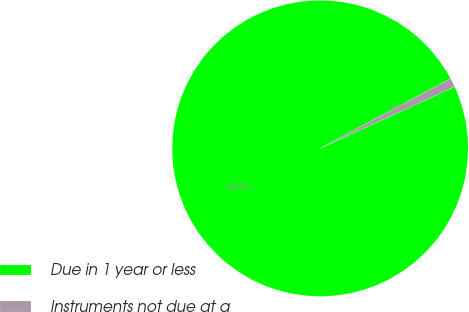Convert chart. <chart><loc_0><loc_0><loc_500><loc_500><pie_chart><fcel>Due in 1 year or less<fcel>Instruments not due at a<nl><fcel>99.02%<fcel>0.98%<nl></chart> 